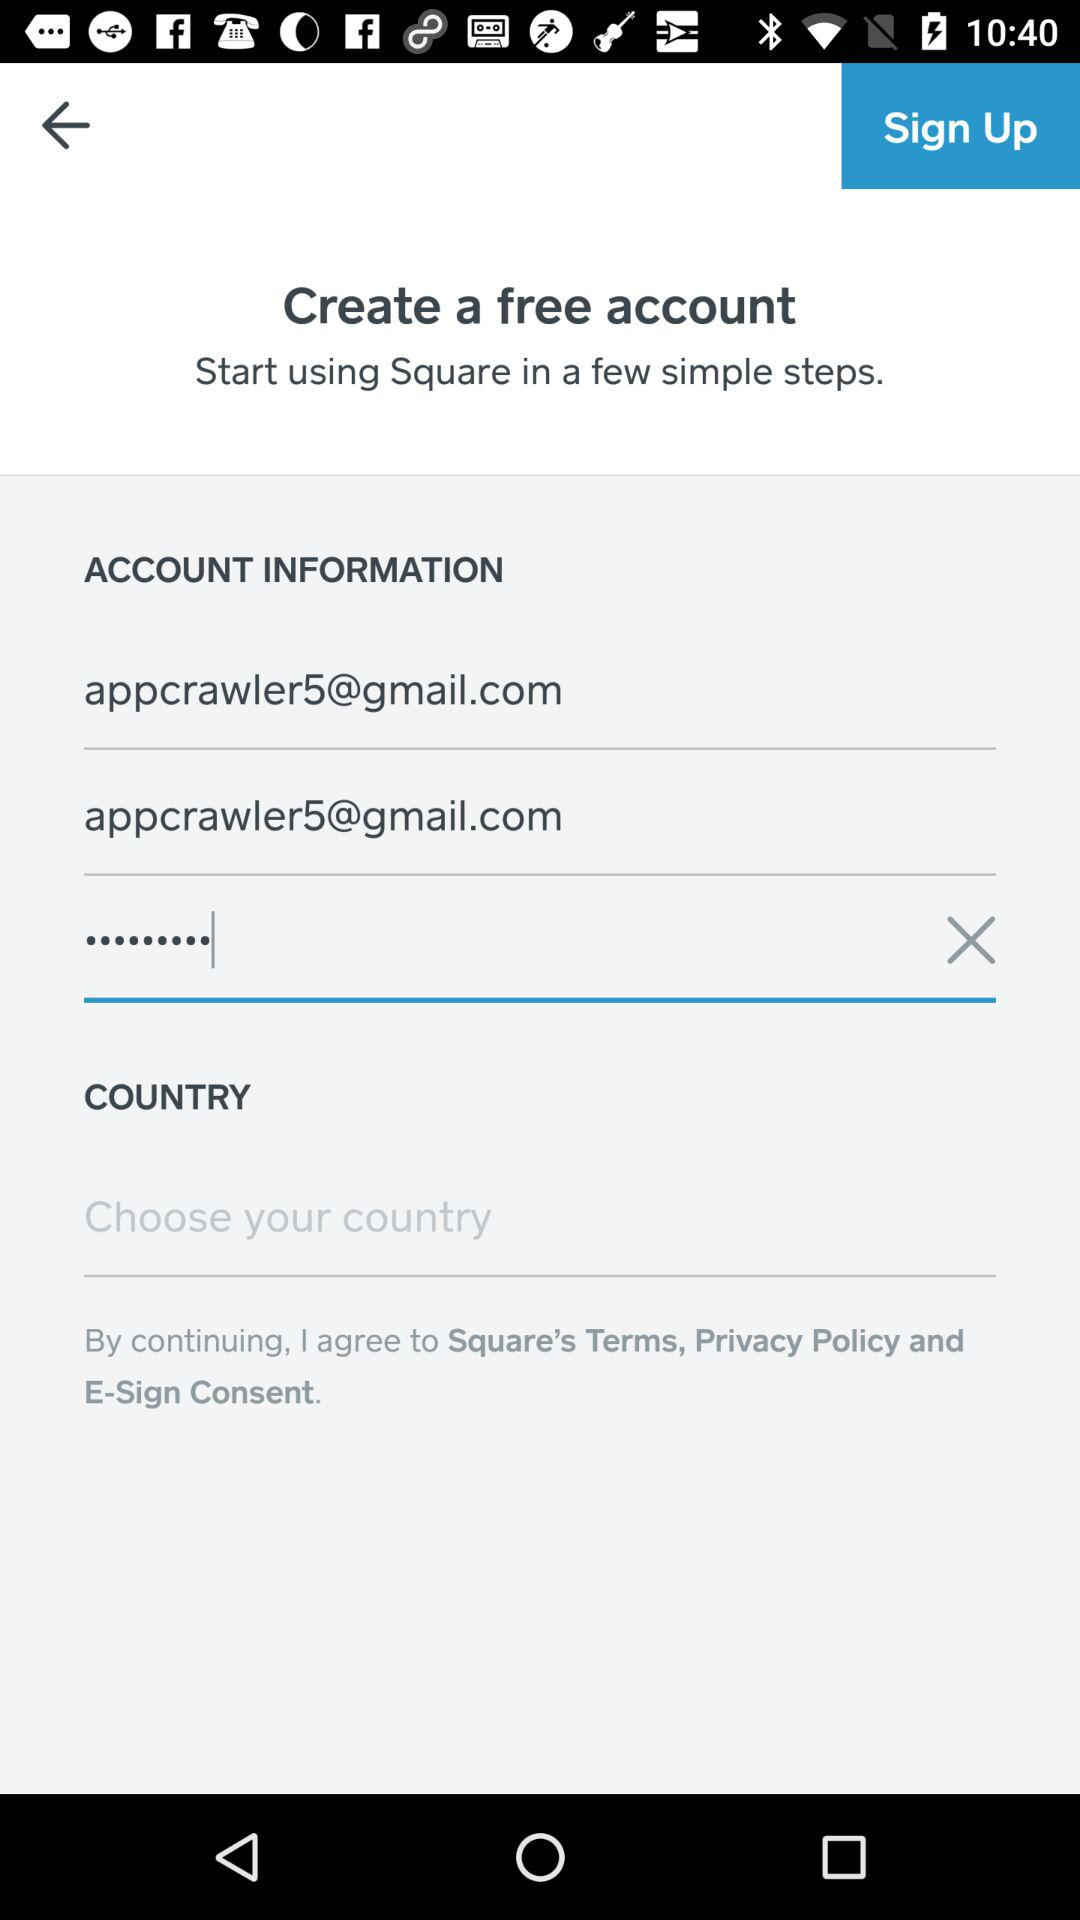How many text inputs are there with an email address in them?
Answer the question using a single word or phrase. 2 